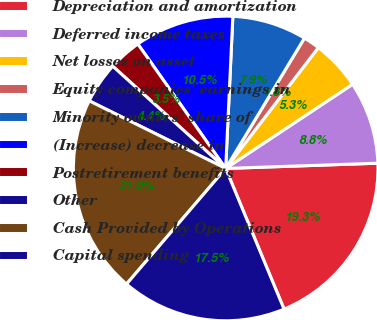Convert chart to OTSL. <chart><loc_0><loc_0><loc_500><loc_500><pie_chart><fcel>Depreciation and amortization<fcel>Deferred income taxes<fcel>Net losses on asset<fcel>Equity companies' earnings in<fcel>Minority owners' share of<fcel>(Increase) decrease in<fcel>Postretirement benefits<fcel>Other<fcel>Cash Provided by Operations<fcel>Capital spending<nl><fcel>19.29%<fcel>8.77%<fcel>5.27%<fcel>1.76%<fcel>7.9%<fcel>10.53%<fcel>3.51%<fcel>4.39%<fcel>21.04%<fcel>17.54%<nl></chart> 